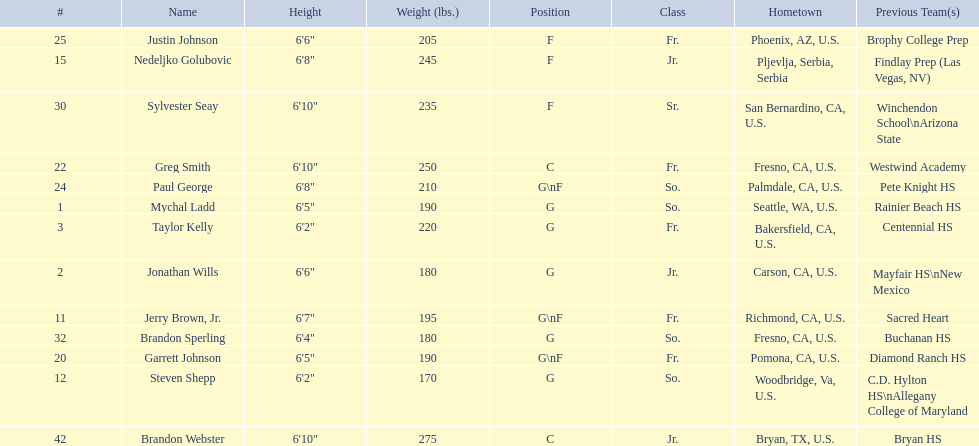Where were all of the players born? So., Jr., Fr., Fr., So., Jr., Fr., Fr., So., Fr., Sr., So., Jr. Who is the one from serbia? Nedeljko Golubovic. 